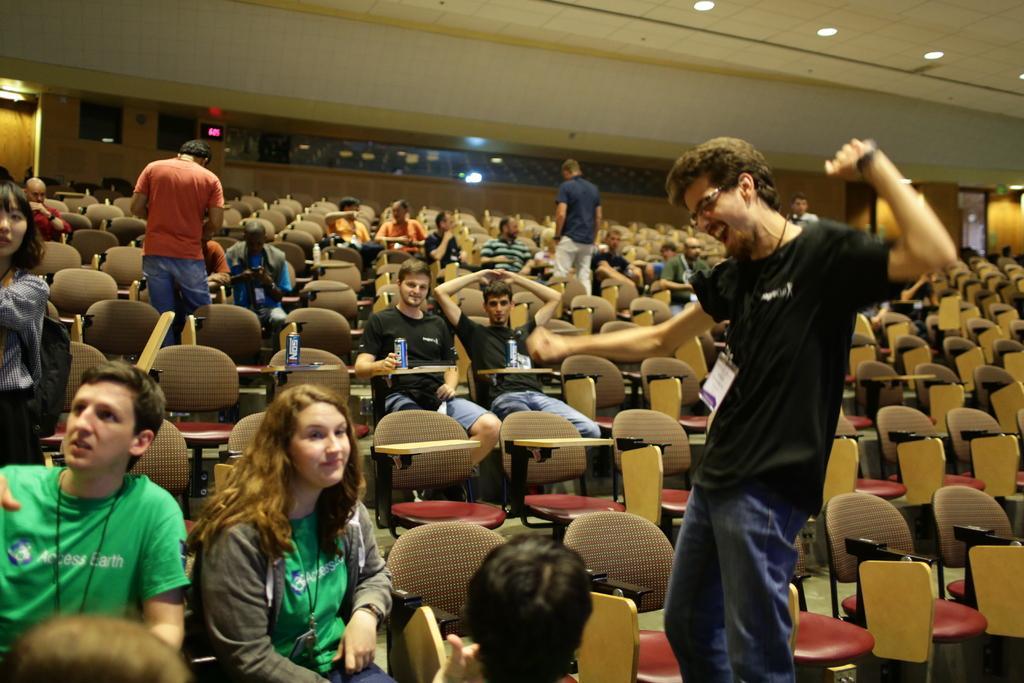How would you summarize this image in a sentence or two? In this picture there are group of people where few among them are sitting in chairs and the remaining are standing. 